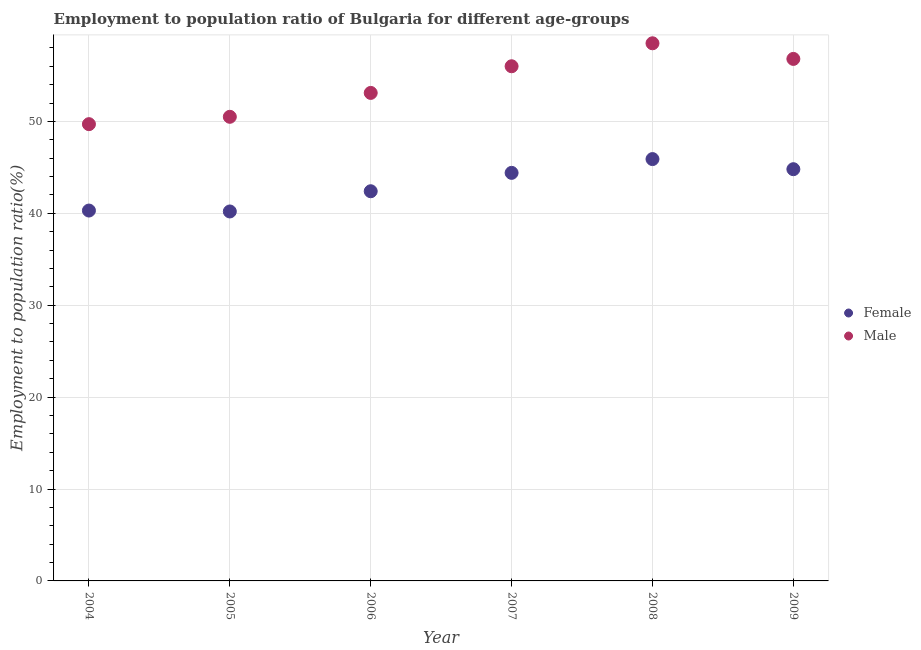How many different coloured dotlines are there?
Provide a short and direct response. 2. Is the number of dotlines equal to the number of legend labels?
Provide a short and direct response. Yes. What is the employment to population ratio(male) in 2005?
Keep it short and to the point. 50.5. Across all years, what is the maximum employment to population ratio(female)?
Make the answer very short. 45.9. Across all years, what is the minimum employment to population ratio(male)?
Provide a succinct answer. 49.7. In which year was the employment to population ratio(female) minimum?
Your answer should be compact. 2005. What is the total employment to population ratio(male) in the graph?
Offer a very short reply. 324.6. What is the difference between the employment to population ratio(male) in 2006 and that in 2007?
Your answer should be very brief. -2.9. What is the difference between the employment to population ratio(female) in 2005 and the employment to population ratio(male) in 2009?
Ensure brevity in your answer.  -16.6. What is the average employment to population ratio(male) per year?
Make the answer very short. 54.1. In the year 2009, what is the difference between the employment to population ratio(female) and employment to population ratio(male)?
Make the answer very short. -12. In how many years, is the employment to population ratio(female) greater than 28 %?
Your answer should be compact. 6. What is the ratio of the employment to population ratio(male) in 2004 to that in 2006?
Give a very brief answer. 0.94. Is the employment to population ratio(female) in 2007 less than that in 2009?
Your response must be concise. Yes. Is the difference between the employment to population ratio(male) in 2004 and 2007 greater than the difference between the employment to population ratio(female) in 2004 and 2007?
Offer a very short reply. No. What is the difference between the highest and the second highest employment to population ratio(female)?
Offer a terse response. 1.1. What is the difference between the highest and the lowest employment to population ratio(male)?
Keep it short and to the point. 8.8. Does the employment to population ratio(female) monotonically increase over the years?
Ensure brevity in your answer.  No. Is the employment to population ratio(male) strictly less than the employment to population ratio(female) over the years?
Provide a succinct answer. No. What is the difference between two consecutive major ticks on the Y-axis?
Ensure brevity in your answer.  10. Are the values on the major ticks of Y-axis written in scientific E-notation?
Ensure brevity in your answer.  No. Does the graph contain any zero values?
Provide a short and direct response. No. Does the graph contain grids?
Offer a very short reply. Yes. Where does the legend appear in the graph?
Offer a terse response. Center right. How are the legend labels stacked?
Keep it short and to the point. Vertical. What is the title of the graph?
Make the answer very short. Employment to population ratio of Bulgaria for different age-groups. Does "Diesel" appear as one of the legend labels in the graph?
Make the answer very short. No. What is the Employment to population ratio(%) of Female in 2004?
Make the answer very short. 40.3. What is the Employment to population ratio(%) in Male in 2004?
Keep it short and to the point. 49.7. What is the Employment to population ratio(%) of Female in 2005?
Provide a short and direct response. 40.2. What is the Employment to population ratio(%) in Male in 2005?
Your answer should be compact. 50.5. What is the Employment to population ratio(%) in Female in 2006?
Keep it short and to the point. 42.4. What is the Employment to population ratio(%) of Male in 2006?
Your response must be concise. 53.1. What is the Employment to population ratio(%) in Female in 2007?
Provide a succinct answer. 44.4. What is the Employment to population ratio(%) in Female in 2008?
Ensure brevity in your answer.  45.9. What is the Employment to population ratio(%) of Male in 2008?
Make the answer very short. 58.5. What is the Employment to population ratio(%) in Female in 2009?
Keep it short and to the point. 44.8. What is the Employment to population ratio(%) of Male in 2009?
Your response must be concise. 56.8. Across all years, what is the maximum Employment to population ratio(%) in Female?
Provide a succinct answer. 45.9. Across all years, what is the maximum Employment to population ratio(%) in Male?
Ensure brevity in your answer.  58.5. Across all years, what is the minimum Employment to population ratio(%) of Female?
Your answer should be very brief. 40.2. Across all years, what is the minimum Employment to population ratio(%) of Male?
Your answer should be very brief. 49.7. What is the total Employment to population ratio(%) of Female in the graph?
Your response must be concise. 258. What is the total Employment to population ratio(%) of Male in the graph?
Your answer should be very brief. 324.6. What is the difference between the Employment to population ratio(%) in Female in 2004 and that in 2005?
Give a very brief answer. 0.1. What is the difference between the Employment to population ratio(%) in Female in 2004 and that in 2008?
Provide a short and direct response. -5.6. What is the difference between the Employment to population ratio(%) of Female in 2004 and that in 2009?
Your response must be concise. -4.5. What is the difference between the Employment to population ratio(%) in Male in 2004 and that in 2009?
Make the answer very short. -7.1. What is the difference between the Employment to population ratio(%) in Female in 2005 and that in 2006?
Provide a short and direct response. -2.2. What is the difference between the Employment to population ratio(%) in Female in 2005 and that in 2007?
Make the answer very short. -4.2. What is the difference between the Employment to population ratio(%) of Male in 2005 and that in 2007?
Your answer should be compact. -5.5. What is the difference between the Employment to population ratio(%) of Male in 2005 and that in 2009?
Ensure brevity in your answer.  -6.3. What is the difference between the Employment to population ratio(%) in Female in 2006 and that in 2007?
Keep it short and to the point. -2. What is the difference between the Employment to population ratio(%) in Female in 2006 and that in 2009?
Ensure brevity in your answer.  -2.4. What is the difference between the Employment to population ratio(%) in Female in 2007 and that in 2008?
Your response must be concise. -1.5. What is the difference between the Employment to population ratio(%) of Male in 2007 and that in 2009?
Provide a short and direct response. -0.8. What is the difference between the Employment to population ratio(%) in Male in 2008 and that in 2009?
Provide a succinct answer. 1.7. What is the difference between the Employment to population ratio(%) of Female in 2004 and the Employment to population ratio(%) of Male in 2007?
Keep it short and to the point. -15.7. What is the difference between the Employment to population ratio(%) of Female in 2004 and the Employment to population ratio(%) of Male in 2008?
Offer a terse response. -18.2. What is the difference between the Employment to population ratio(%) in Female in 2004 and the Employment to population ratio(%) in Male in 2009?
Provide a short and direct response. -16.5. What is the difference between the Employment to population ratio(%) in Female in 2005 and the Employment to population ratio(%) in Male in 2006?
Your answer should be compact. -12.9. What is the difference between the Employment to population ratio(%) in Female in 2005 and the Employment to population ratio(%) in Male in 2007?
Offer a very short reply. -15.8. What is the difference between the Employment to population ratio(%) of Female in 2005 and the Employment to population ratio(%) of Male in 2008?
Offer a very short reply. -18.3. What is the difference between the Employment to population ratio(%) of Female in 2005 and the Employment to population ratio(%) of Male in 2009?
Your answer should be compact. -16.6. What is the difference between the Employment to population ratio(%) in Female in 2006 and the Employment to population ratio(%) in Male in 2007?
Provide a succinct answer. -13.6. What is the difference between the Employment to population ratio(%) of Female in 2006 and the Employment to population ratio(%) of Male in 2008?
Your answer should be compact. -16.1. What is the difference between the Employment to population ratio(%) in Female in 2006 and the Employment to population ratio(%) in Male in 2009?
Your answer should be compact. -14.4. What is the difference between the Employment to population ratio(%) in Female in 2007 and the Employment to population ratio(%) in Male in 2008?
Ensure brevity in your answer.  -14.1. What is the difference between the Employment to population ratio(%) in Female in 2008 and the Employment to population ratio(%) in Male in 2009?
Keep it short and to the point. -10.9. What is the average Employment to population ratio(%) in Female per year?
Offer a very short reply. 43. What is the average Employment to population ratio(%) of Male per year?
Provide a short and direct response. 54.1. In the year 2004, what is the difference between the Employment to population ratio(%) in Female and Employment to population ratio(%) in Male?
Your response must be concise. -9.4. In the year 2006, what is the difference between the Employment to population ratio(%) of Female and Employment to population ratio(%) of Male?
Give a very brief answer. -10.7. In the year 2007, what is the difference between the Employment to population ratio(%) in Female and Employment to population ratio(%) in Male?
Your answer should be very brief. -11.6. In the year 2008, what is the difference between the Employment to population ratio(%) in Female and Employment to population ratio(%) in Male?
Give a very brief answer. -12.6. In the year 2009, what is the difference between the Employment to population ratio(%) of Female and Employment to population ratio(%) of Male?
Give a very brief answer. -12. What is the ratio of the Employment to population ratio(%) in Female in 2004 to that in 2005?
Ensure brevity in your answer.  1. What is the ratio of the Employment to population ratio(%) in Male in 2004 to that in 2005?
Your answer should be very brief. 0.98. What is the ratio of the Employment to population ratio(%) in Female in 2004 to that in 2006?
Provide a succinct answer. 0.95. What is the ratio of the Employment to population ratio(%) in Male in 2004 to that in 2006?
Your answer should be compact. 0.94. What is the ratio of the Employment to population ratio(%) of Female in 2004 to that in 2007?
Offer a terse response. 0.91. What is the ratio of the Employment to population ratio(%) in Male in 2004 to that in 2007?
Your answer should be compact. 0.89. What is the ratio of the Employment to population ratio(%) in Female in 2004 to that in 2008?
Provide a succinct answer. 0.88. What is the ratio of the Employment to population ratio(%) in Male in 2004 to that in 2008?
Make the answer very short. 0.85. What is the ratio of the Employment to population ratio(%) of Female in 2004 to that in 2009?
Ensure brevity in your answer.  0.9. What is the ratio of the Employment to population ratio(%) of Female in 2005 to that in 2006?
Your answer should be very brief. 0.95. What is the ratio of the Employment to population ratio(%) in Male in 2005 to that in 2006?
Your response must be concise. 0.95. What is the ratio of the Employment to population ratio(%) of Female in 2005 to that in 2007?
Offer a very short reply. 0.91. What is the ratio of the Employment to population ratio(%) in Male in 2005 to that in 2007?
Your answer should be compact. 0.9. What is the ratio of the Employment to population ratio(%) in Female in 2005 to that in 2008?
Provide a succinct answer. 0.88. What is the ratio of the Employment to population ratio(%) of Male in 2005 to that in 2008?
Make the answer very short. 0.86. What is the ratio of the Employment to population ratio(%) in Female in 2005 to that in 2009?
Offer a terse response. 0.9. What is the ratio of the Employment to population ratio(%) in Male in 2005 to that in 2009?
Provide a succinct answer. 0.89. What is the ratio of the Employment to population ratio(%) in Female in 2006 to that in 2007?
Make the answer very short. 0.95. What is the ratio of the Employment to population ratio(%) in Male in 2006 to that in 2007?
Ensure brevity in your answer.  0.95. What is the ratio of the Employment to population ratio(%) of Female in 2006 to that in 2008?
Keep it short and to the point. 0.92. What is the ratio of the Employment to population ratio(%) of Male in 2006 to that in 2008?
Provide a succinct answer. 0.91. What is the ratio of the Employment to population ratio(%) of Female in 2006 to that in 2009?
Provide a short and direct response. 0.95. What is the ratio of the Employment to population ratio(%) of Male in 2006 to that in 2009?
Ensure brevity in your answer.  0.93. What is the ratio of the Employment to population ratio(%) in Female in 2007 to that in 2008?
Your answer should be very brief. 0.97. What is the ratio of the Employment to population ratio(%) in Male in 2007 to that in 2008?
Make the answer very short. 0.96. What is the ratio of the Employment to population ratio(%) of Male in 2007 to that in 2009?
Your answer should be compact. 0.99. What is the ratio of the Employment to population ratio(%) in Female in 2008 to that in 2009?
Provide a succinct answer. 1.02. What is the ratio of the Employment to population ratio(%) in Male in 2008 to that in 2009?
Offer a very short reply. 1.03. What is the difference between the highest and the second highest Employment to population ratio(%) of Female?
Your answer should be very brief. 1.1. What is the difference between the highest and the lowest Employment to population ratio(%) of Female?
Provide a short and direct response. 5.7. 